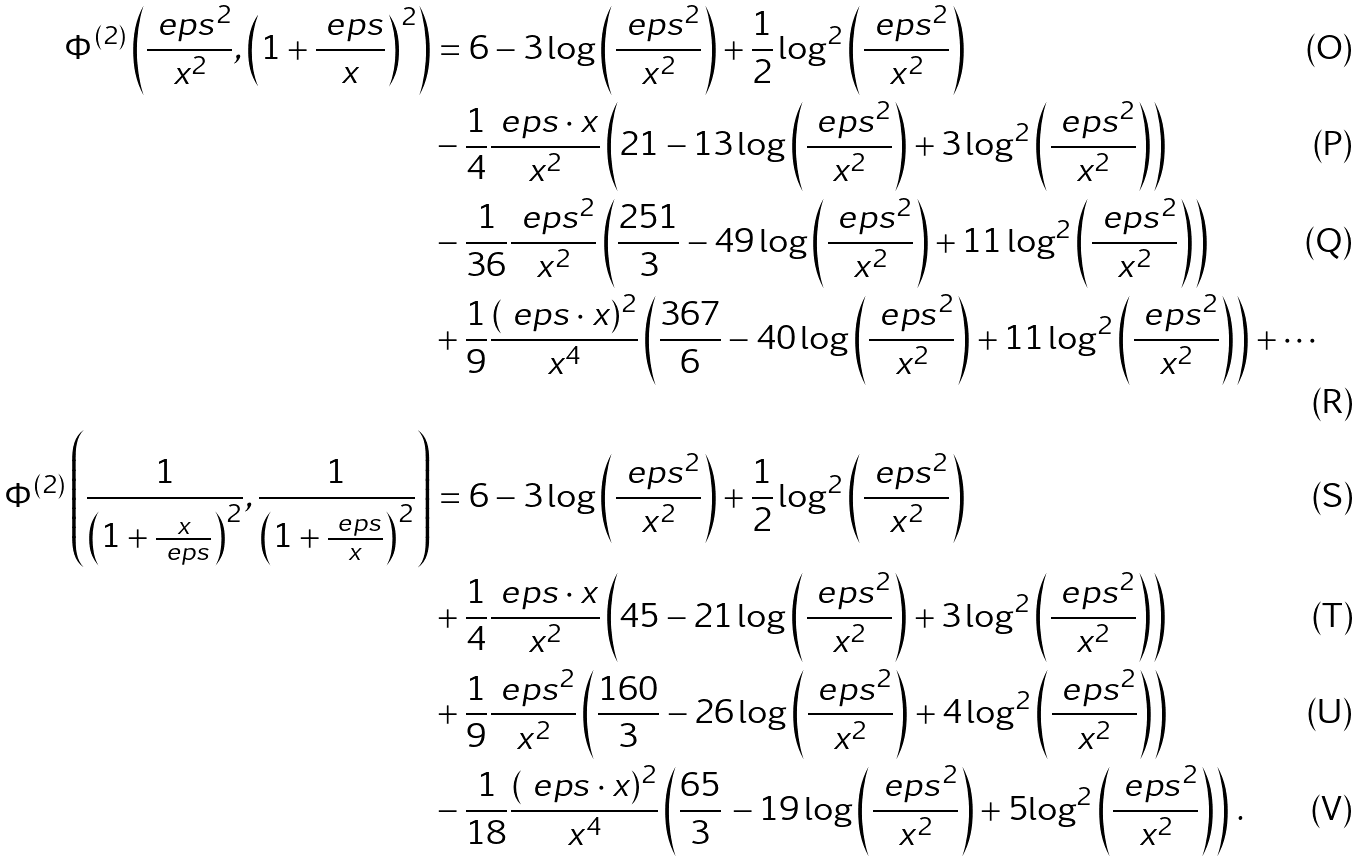Convert formula to latex. <formula><loc_0><loc_0><loc_500><loc_500>\Phi ^ { ( 2 ) } \left ( \frac { \ e p s ^ { 2 } } { x ^ { 2 } } , \left ( 1 + \frac { \ e p s } { x } \right ) ^ { 2 } \right ) & = 6 - 3 \log \left ( \frac { \ e p s ^ { 2 } } { x ^ { 2 } } \right ) + \frac { 1 } { 2 } \log ^ { 2 } \left ( \frac { \ e p s ^ { 2 } } { x ^ { 2 } } \right ) \\ & - \frac { 1 } { 4 } \frac { \ e p s \cdot x } { x ^ { 2 } } \left ( 2 1 - 1 3 \log \left ( \frac { \ e p s ^ { 2 } } { x ^ { 2 } } \right ) + 3 \log ^ { 2 } \left ( \frac { \ e p s ^ { 2 } } { x ^ { 2 } } \right ) \right ) \\ & - \frac { 1 } { 3 6 } \frac { \ e p s ^ { 2 } } { x ^ { 2 } } \left ( \frac { 2 5 1 } { 3 } - 4 9 \log \left ( \frac { \ e p s ^ { 2 } } { x ^ { 2 } } \right ) + 1 1 \log ^ { 2 } \left ( \frac { \ e p s ^ { 2 } } { x ^ { 2 } } \right ) \right ) \\ & + \frac { 1 } { 9 } \frac { ( \ e p s \cdot x ) ^ { 2 } } { x ^ { 4 } } \left ( \frac { 3 6 7 } { 6 } - 4 0 \log \left ( \frac { \ e p s ^ { 2 } } { x ^ { 2 } } \right ) + 1 1 \log ^ { 2 } \left ( \frac { \ e p s ^ { 2 } } { x ^ { 2 } } \right ) \right ) + \cdots \\ \Phi ^ { ( 2 ) } \left ( \frac { 1 } { \left ( 1 + \frac { x } { \ e p s } \right ) ^ { 2 } } , \frac { 1 } { \left ( 1 + \frac { \ e p s } { x } \right ) ^ { 2 } } \right ) & = 6 - 3 \log \left ( \frac { \ e p s ^ { 2 } } { x ^ { 2 } } \right ) + \frac { 1 } { 2 } \log ^ { 2 } \left ( \frac { \ e p s ^ { 2 } } { x ^ { 2 } } \right ) \\ & + \frac { 1 } { 4 } \frac { \ e p s \cdot x } { x ^ { 2 } } \left ( 4 5 - 2 1 \log \left ( \frac { \ e p s ^ { 2 } } { x ^ { 2 } } \right ) + 3 \log ^ { 2 } \left ( \frac { \ e p s ^ { 2 } } { x ^ { 2 } } \right ) \right ) \\ & + \frac { 1 } { 9 } \frac { \ e p s ^ { 2 } } { x ^ { 2 } } \left ( \frac { 1 6 0 } { 3 } - 2 6 \log \left ( \frac { \ e p s ^ { 2 } } { x ^ { 2 } } \right ) + 4 \log ^ { 2 } \left ( \frac { \ e p s ^ { 2 } } { x ^ { 2 } } \right ) \right ) \\ & - \frac { 1 } { 1 8 } { \frac { ( \ e p s \cdot x ) ^ { 2 } } { { x } ^ { 4 } } } \left ( { \frac { 6 5 } { 3 } } \, - 1 9 \log \left ( \frac { \ e p s ^ { 2 } } { x ^ { 2 } } \right ) + 5 { \log ^ { 2 } \left ( \frac { \ e p s ^ { 2 } } { x ^ { 2 } } \right ) } \right ) \, .</formula> 